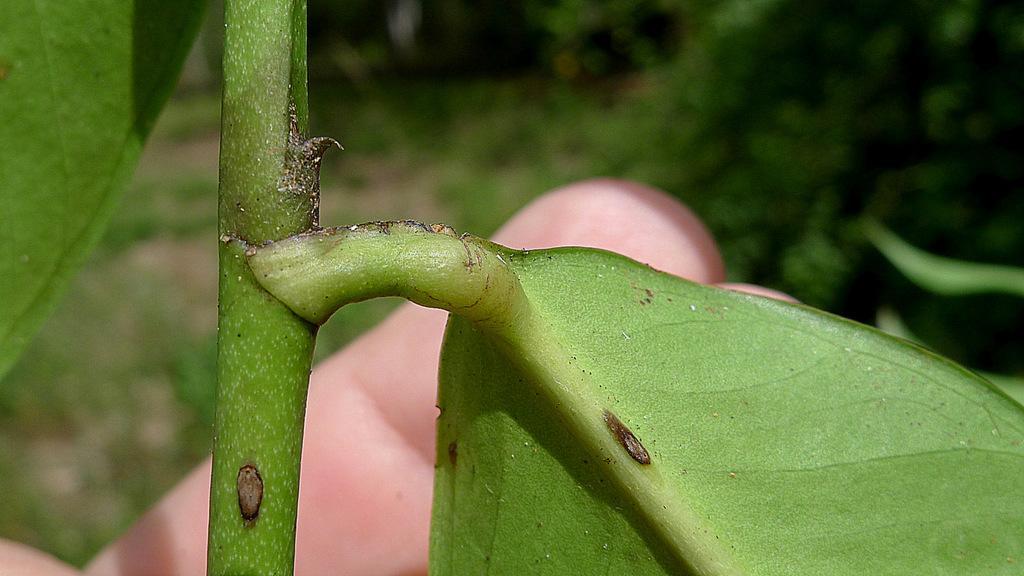In one or two sentences, can you explain what this image depicts? In this image we can see a leaf and a steam which are in green color. In the background of the image is in a blur. 